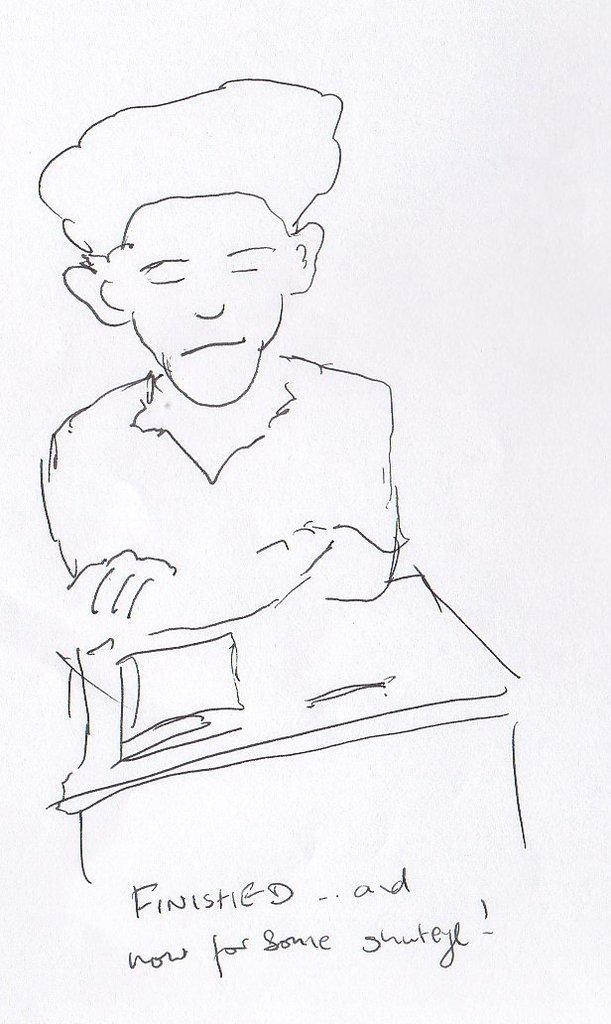How would you summarize this image in a sentence or two? In the center of the image there is a drawing of a person. At the bottom of the image there is text. 